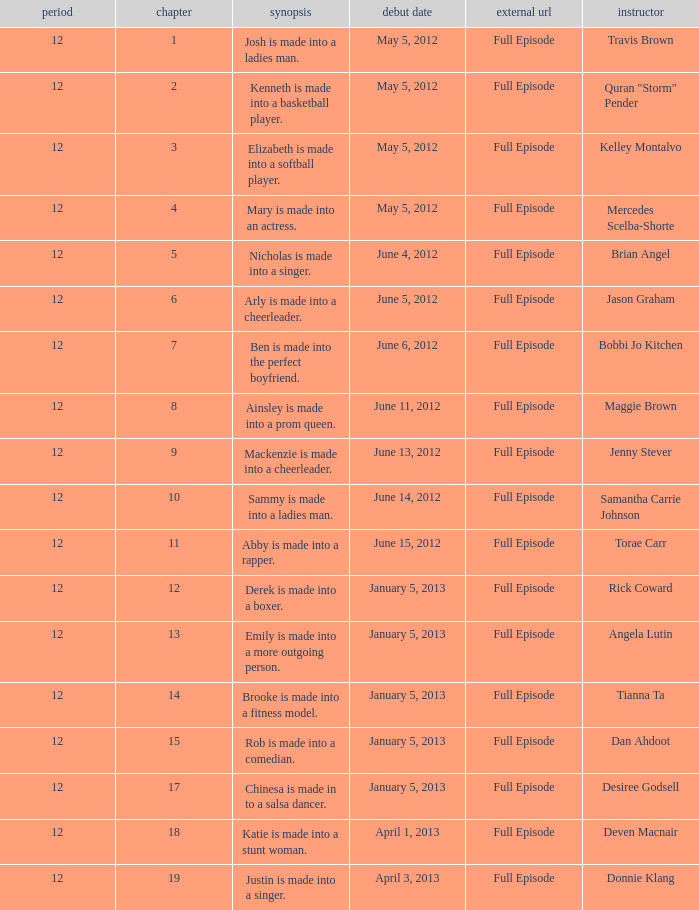Name the episode summary for travis brown Josh is made into a ladies man. 